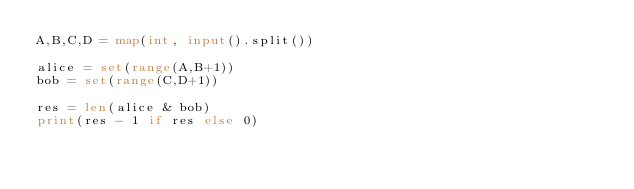<code> <loc_0><loc_0><loc_500><loc_500><_Python_>A,B,C,D = map(int, input().split())

alice = set(range(A,B+1))
bob = set(range(C,D+1))

res = len(alice & bob)
print(res - 1 if res else 0)
</code> 